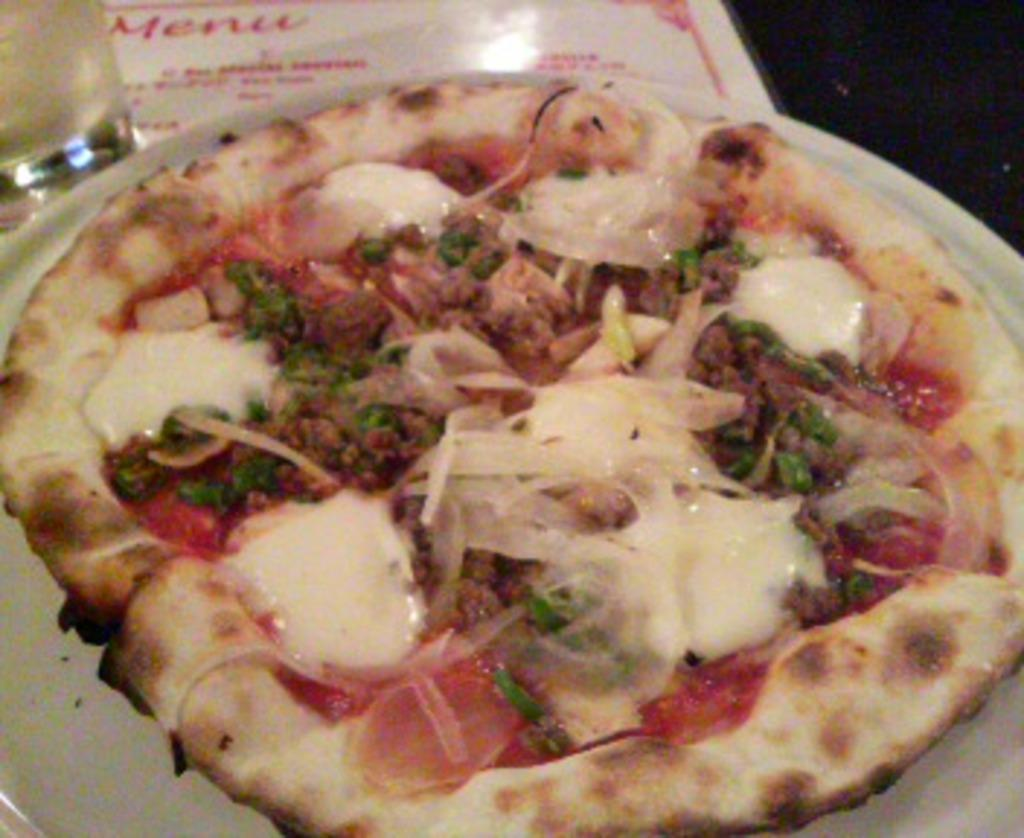What type of food is shown in the image? There is a pizza in the image. What is the pizza placed on? The pizza is on a white plate. What other object can be seen in the image besides the pizza? There is a paper visible in the image. What else is on the table in the image? There is a glass on the table in the image. How many nails are visible in the image? There are no nails present in the image. What impulse might the person in the image be experiencing? There is no person present in the image, so it is impossible to determine any impulses they might be experiencing. 